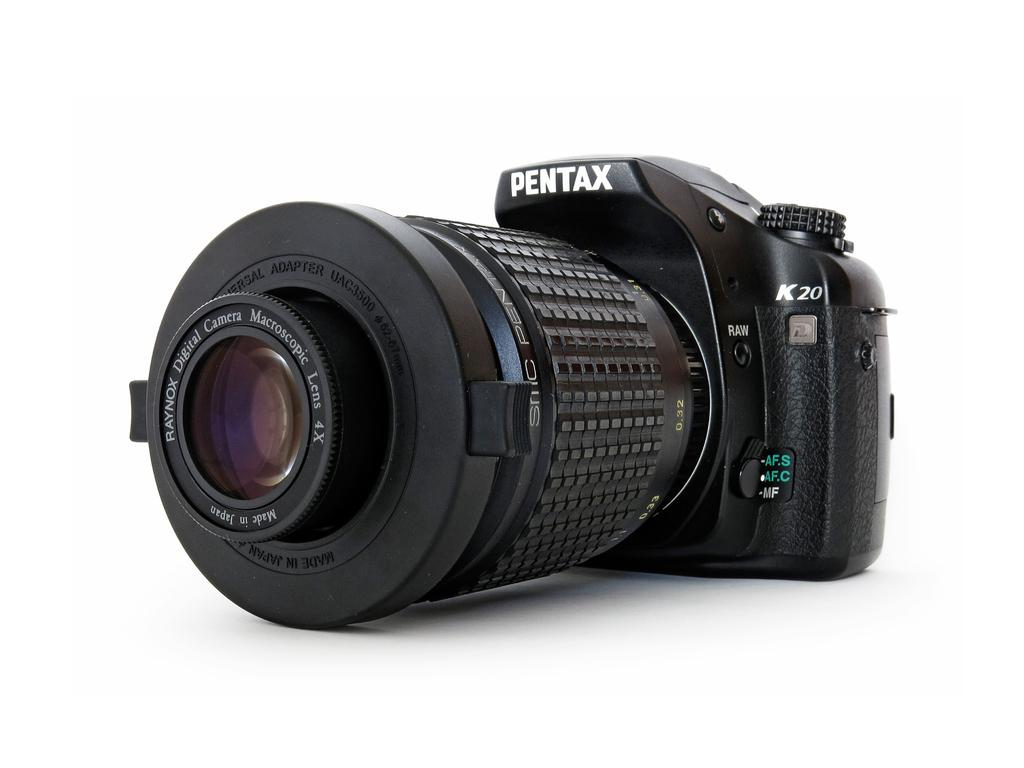What object is the main subject of the image? There is a black camera in the image. What part of the camera is used for capturing images? The camera has a lens. On what surface is the camera placed? The camera is on a white surface. What color is the background of the image? The background of the image is white. How many dogs are visible in the image? There are no dogs present in the image; it features a black camera on a white surface with a white background. Are there any horses in the image? There are no horses present in the image; it features a black camera on a white surface with a white background. 